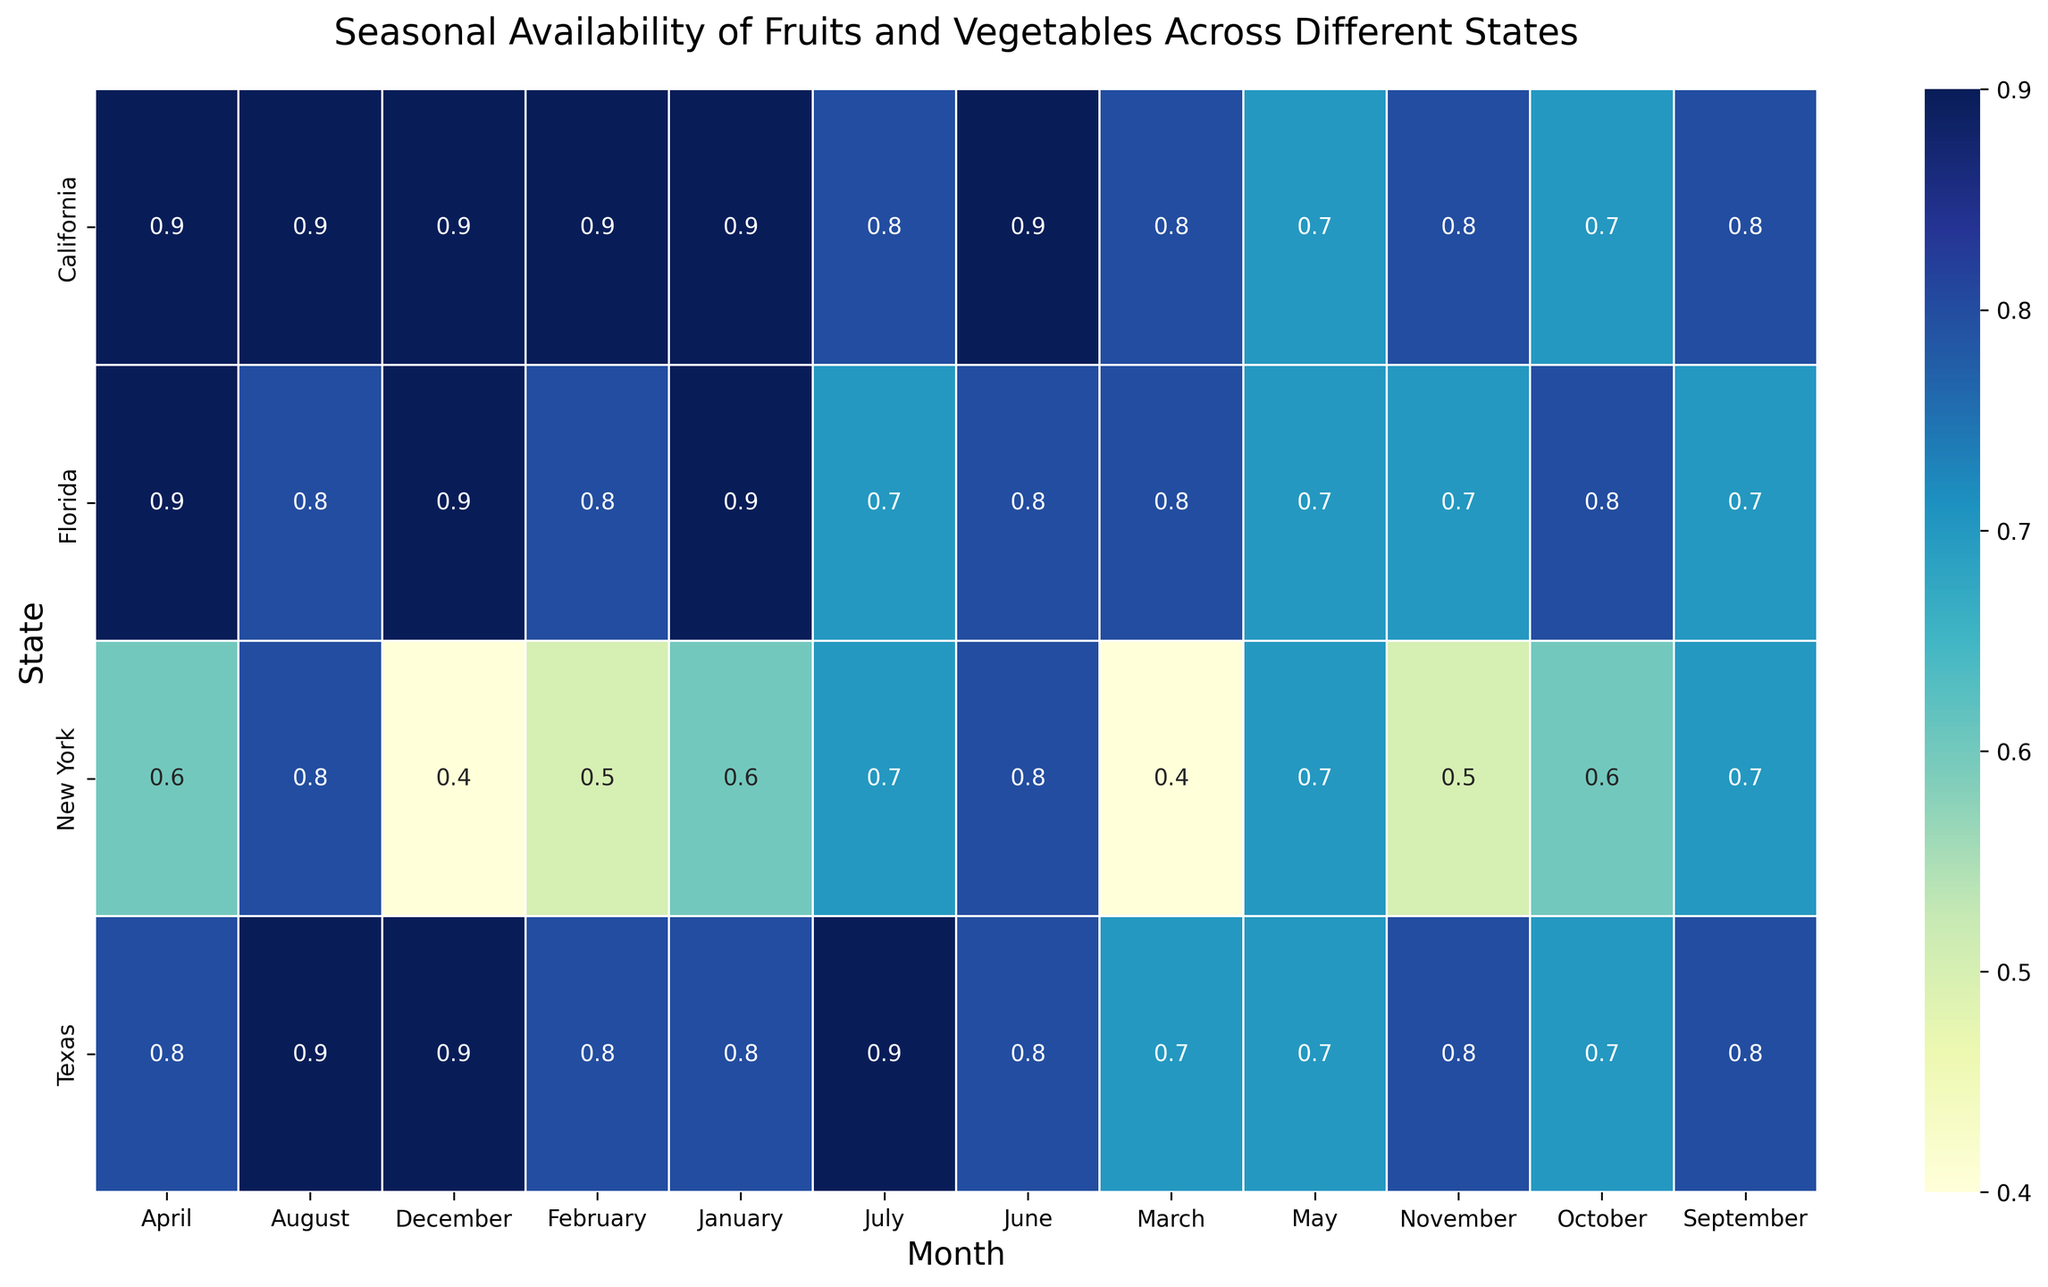Which state has the highest average availability score across all months? To find this, we need to calculate the average availability score for each state across all months. Once calculated, compare the averages to determine the highest one.
Answer: California Which month has the lowest availability score for fruits and vegetables in New York? Look at the row for New York and identify the column with the lowest score.
Answer: December Which state shows the greatest variation in availability scores across the year? Calculate the range (difference between the highest and lowest values) of scores for each state and identify the state with the largest range.
Answer: New York Which month generally has the highest availability score across all states? Look at each column (each month) and find the month where the average availability score across all states is highest.
Answer: January In which month does California see a decrease in availability score compared to the previous month? Look at the scores for California month by month and find the point where the score goes down compared to the previous month.
Answer: May (0.9 to 0.7) and October (0.8 to 0.7) Which state has the most consistent availability score throughout the year? Consistency can be measured by the smallest variance in scores. Identify the state with the lowest variance in its scores.
Answer: Texas How does the availability score in July compare between California and Texas? Look at the scores for July in both states and compare them.
Answer: California and Texas both have a score of 0.8 and 0.9, respectively For which state does October have a notable drop in availability score compared to September? Look at availability scores from September to October for each state and find which one drops noticeably.
Answer: Notable drops are seen in Texas (0.8 to 0.7) and California (0.8 to 0.7) What is the average availability score for California in the first quarter (January to March)? Calculate the average of the scores for January, February, and March for California.
Answer: (0.9 + 0.9 + 0.8) / 3 = 0.867 How do the availability scores for fruits and vegetables in Florida compare from June to July? Compare the scores for Florida between June and July and observe the trend.
Answer: June (0.8) to July (0.7) 